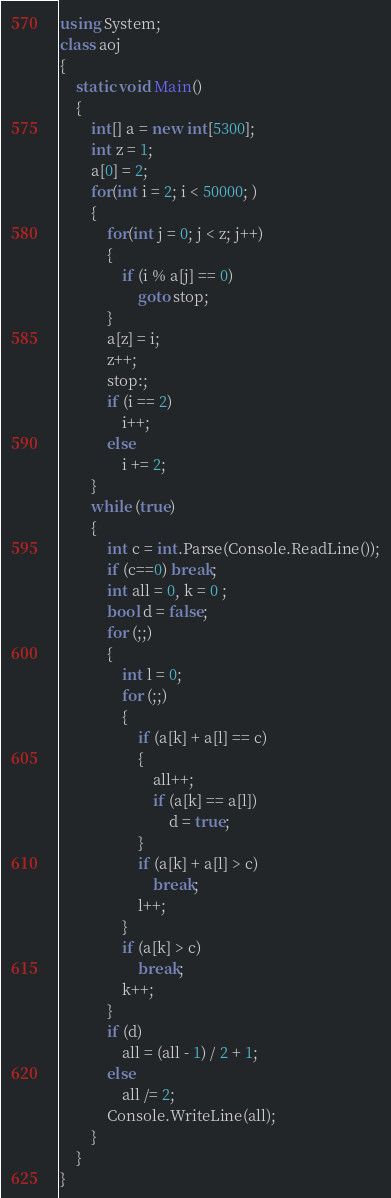Convert code to text. <code><loc_0><loc_0><loc_500><loc_500><_C#_>using System;
class aoj
{
    static void Main()
    {
        int[] a = new int[5300];
        int z = 1;
        a[0] = 2;
        for(int i = 2; i < 50000; )
        {
            for(int j = 0; j < z; j++)
            {
                if (i % a[j] == 0)
                    goto stop;
            }
            a[z] = i;
            z++;
            stop:;
            if (i == 2)
                i++;
            else
                i += 2;
        }
        while (true)
        {
            int c = int.Parse(Console.ReadLine());
            if (c==0) break;
            int all = 0, k = 0 ;
            bool d = false;
            for (;;)
            {
                int l = 0;
                for (;;)
                {
                    if (a[k] + a[l] == c)
                    {
                        all++;
                        if (a[k] == a[l])
                            d = true;
                    }
                    if (a[k] + a[l] > c)
                        break;
                    l++;
                }
                if (a[k] > c)
                    break;
                k++;
            }
            if (d)
                all = (all - 1) / 2 + 1;
            else
                all /= 2;
            Console.WriteLine(all);
        }
    }
}</code> 